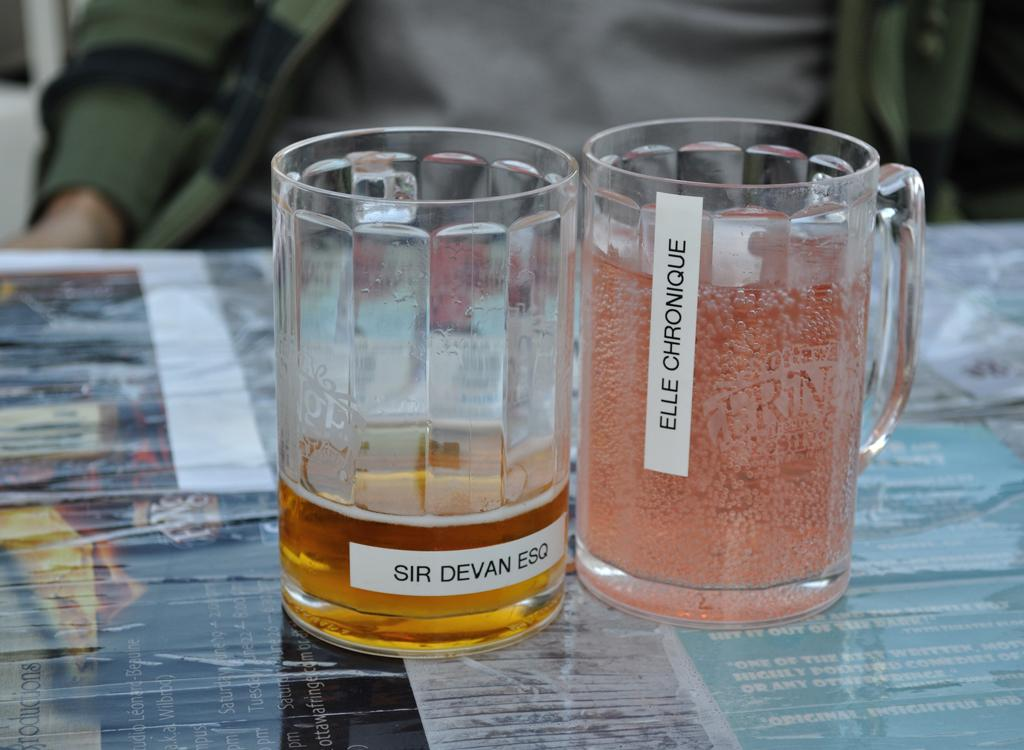<image>
Provide a brief description of the given image. A pint glass sits on the table for Sir Devan Esq. 